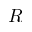Convert formula to latex. <formula><loc_0><loc_0><loc_500><loc_500>R</formula> 